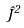<formula> <loc_0><loc_0><loc_500><loc_500>\hat { J } ^ { 2 }</formula> 